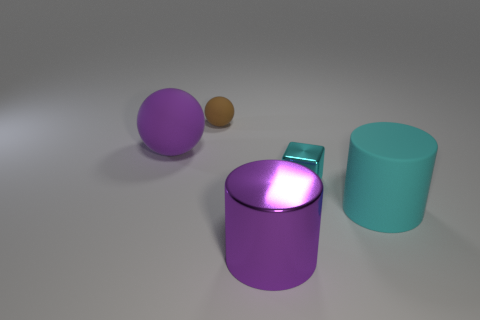Add 4 purple shiny cylinders. How many objects exist? 9 Subtract all cubes. How many objects are left? 4 Subtract all large yellow metallic objects. Subtract all cyan blocks. How many objects are left? 4 Add 3 cyan metal objects. How many cyan metal objects are left? 4 Add 5 small cyan cubes. How many small cyan cubes exist? 6 Subtract 0 brown cylinders. How many objects are left? 5 